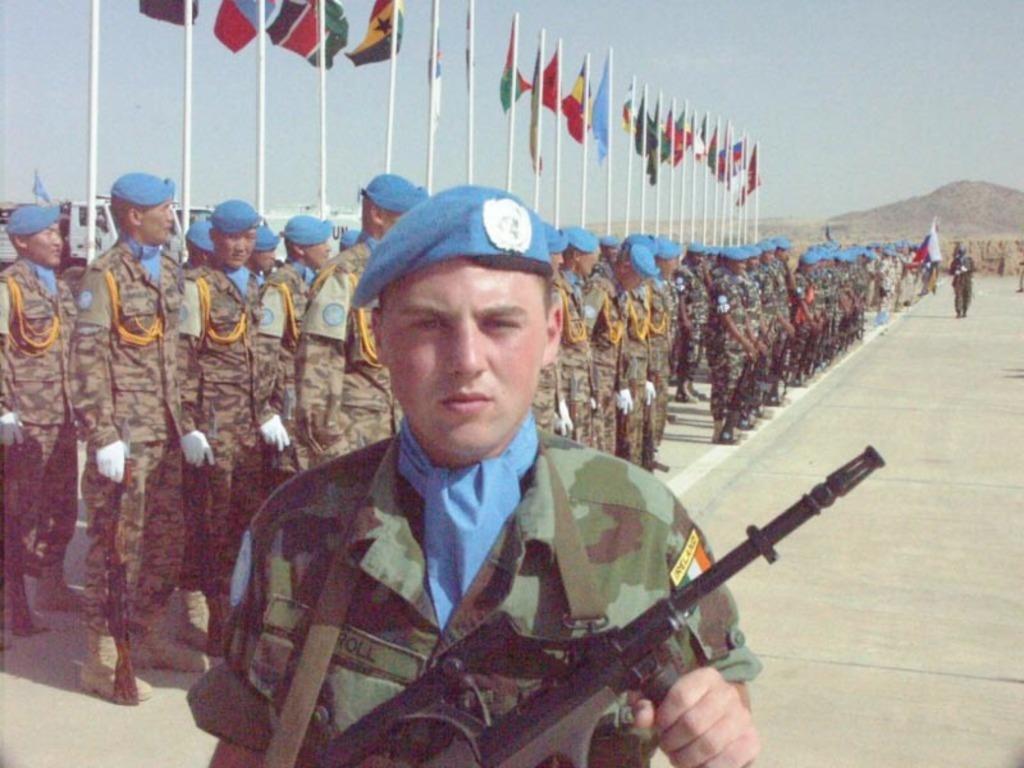Could you give a brief overview of what you see in this image? Here a man is standing by holding a weapon in his hand. He wore a blue color cap behind him a group of people are standing. At the top it's a sunny sky. 